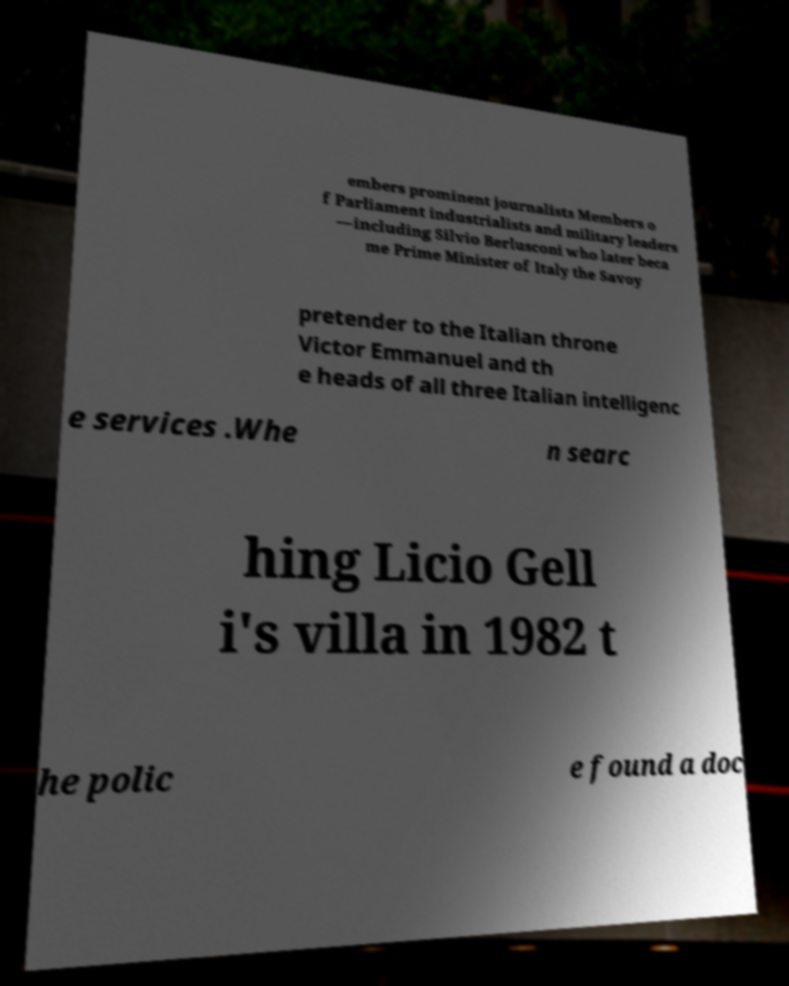Please identify and transcribe the text found in this image. embers prominent journalists Members o f Parliament industrialists and military leaders —including Silvio Berlusconi who later beca me Prime Minister of Italy the Savoy pretender to the Italian throne Victor Emmanuel and th e heads of all three Italian intelligenc e services .Whe n searc hing Licio Gell i's villa in 1982 t he polic e found a doc 